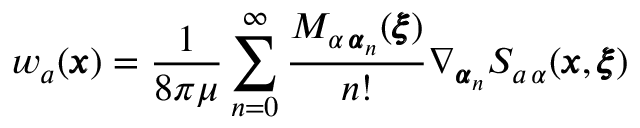Convert formula to latex. <formula><loc_0><loc_0><loc_500><loc_500>w _ { a } ( { \pm b x } ) = \frac { 1 } { 8 \pi \mu } \sum _ { n = 0 } ^ { \infty } \frac { M _ { \alpha \, { \pm b \alpha } _ { n } } ( { \pm b \xi } ) } { n ! } \nabla _ { { \pm b \alpha } _ { n } } S _ { a \, \alpha } ( { \pm b x } , { \pm b \xi } )</formula> 